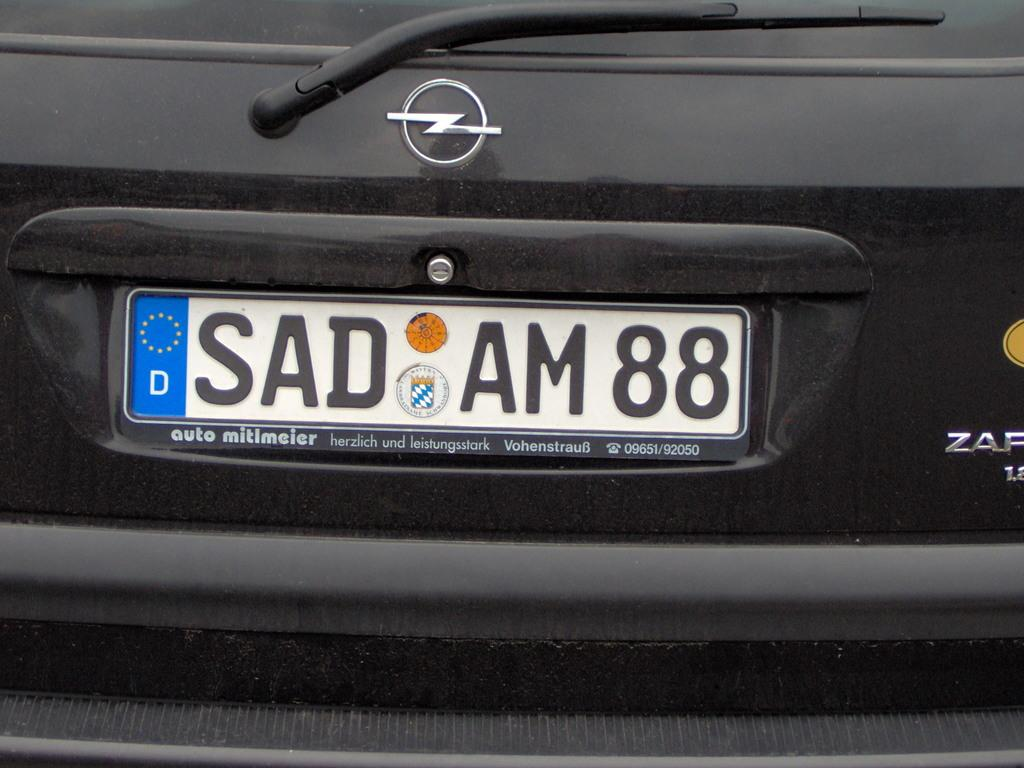<image>
Relay a brief, clear account of the picture shown. The license plate on the back of a black car, with a sideways lightning bolt emblem, reads SAD AM 88. 